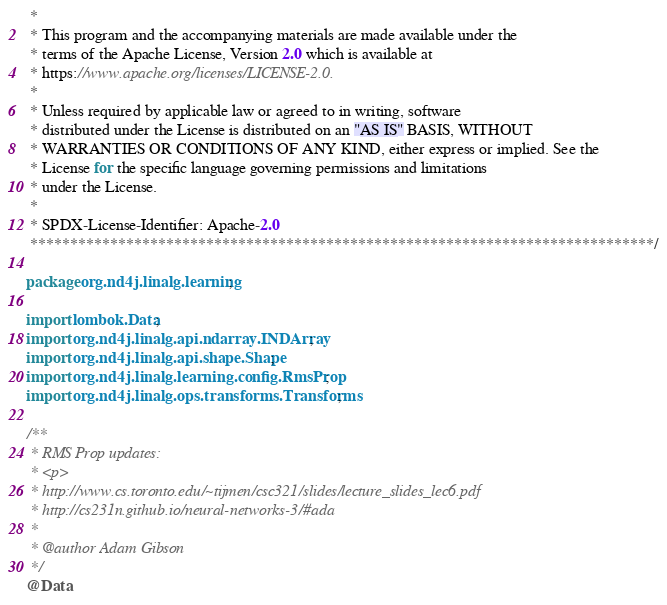<code> <loc_0><loc_0><loc_500><loc_500><_Java_> *
 * This program and the accompanying materials are made available under the
 * terms of the Apache License, Version 2.0 which is available at
 * https://www.apache.org/licenses/LICENSE-2.0.
 *
 * Unless required by applicable law or agreed to in writing, software
 * distributed under the License is distributed on an "AS IS" BASIS, WITHOUT
 * WARRANTIES OR CONDITIONS OF ANY KIND, either express or implied. See the
 * License for the specific language governing permissions and limitations
 * under the License.
 *
 * SPDX-License-Identifier: Apache-2.0
 ******************************************************************************/

package org.nd4j.linalg.learning;

import lombok.Data;
import org.nd4j.linalg.api.ndarray.INDArray;
import org.nd4j.linalg.api.shape.Shape;
import org.nd4j.linalg.learning.config.RmsProp;
import org.nd4j.linalg.ops.transforms.Transforms;

/**
 * RMS Prop updates:
 * <p>
 * http://www.cs.toronto.edu/~tijmen/csc321/slides/lecture_slides_lec6.pdf
 * http://cs231n.github.io/neural-networks-3/#ada
 *
 * @author Adam Gibson
 */
@Data</code> 